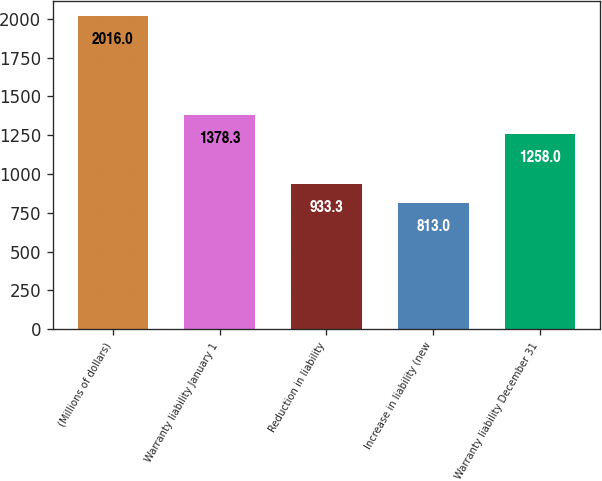<chart> <loc_0><loc_0><loc_500><loc_500><bar_chart><fcel>(Millions of dollars)<fcel>Warranty liability January 1<fcel>Reduction in liability<fcel>Increase in liability (new<fcel>Warranty liability December 31<nl><fcel>2016<fcel>1378.3<fcel>933.3<fcel>813<fcel>1258<nl></chart> 